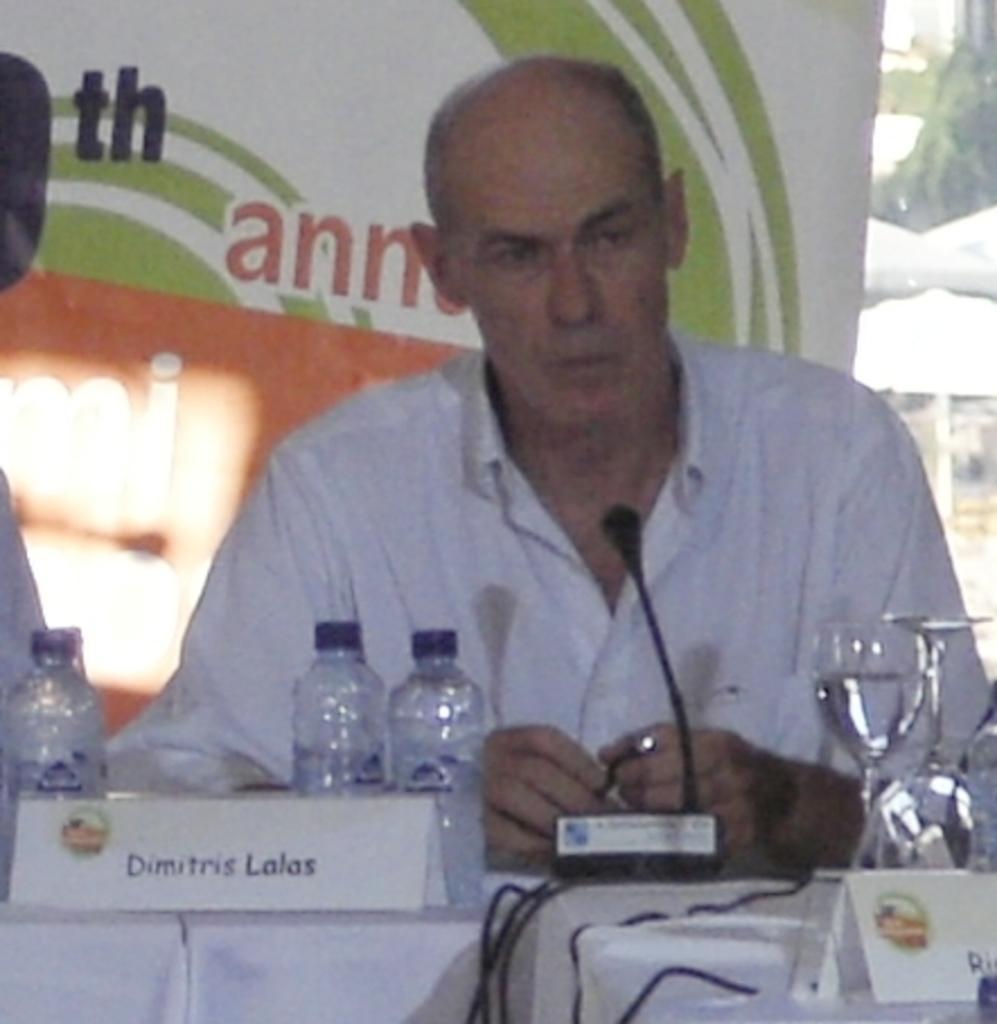In one or two sentences, can you explain what this image depicts? In the middle of the image a man is sitting in front of a microphone, Behind him there is a banner. In front of him there are some water bottles and glasses on the table. 